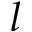Convert formula to latex. <formula><loc_0><loc_0><loc_500><loc_500>l</formula> 